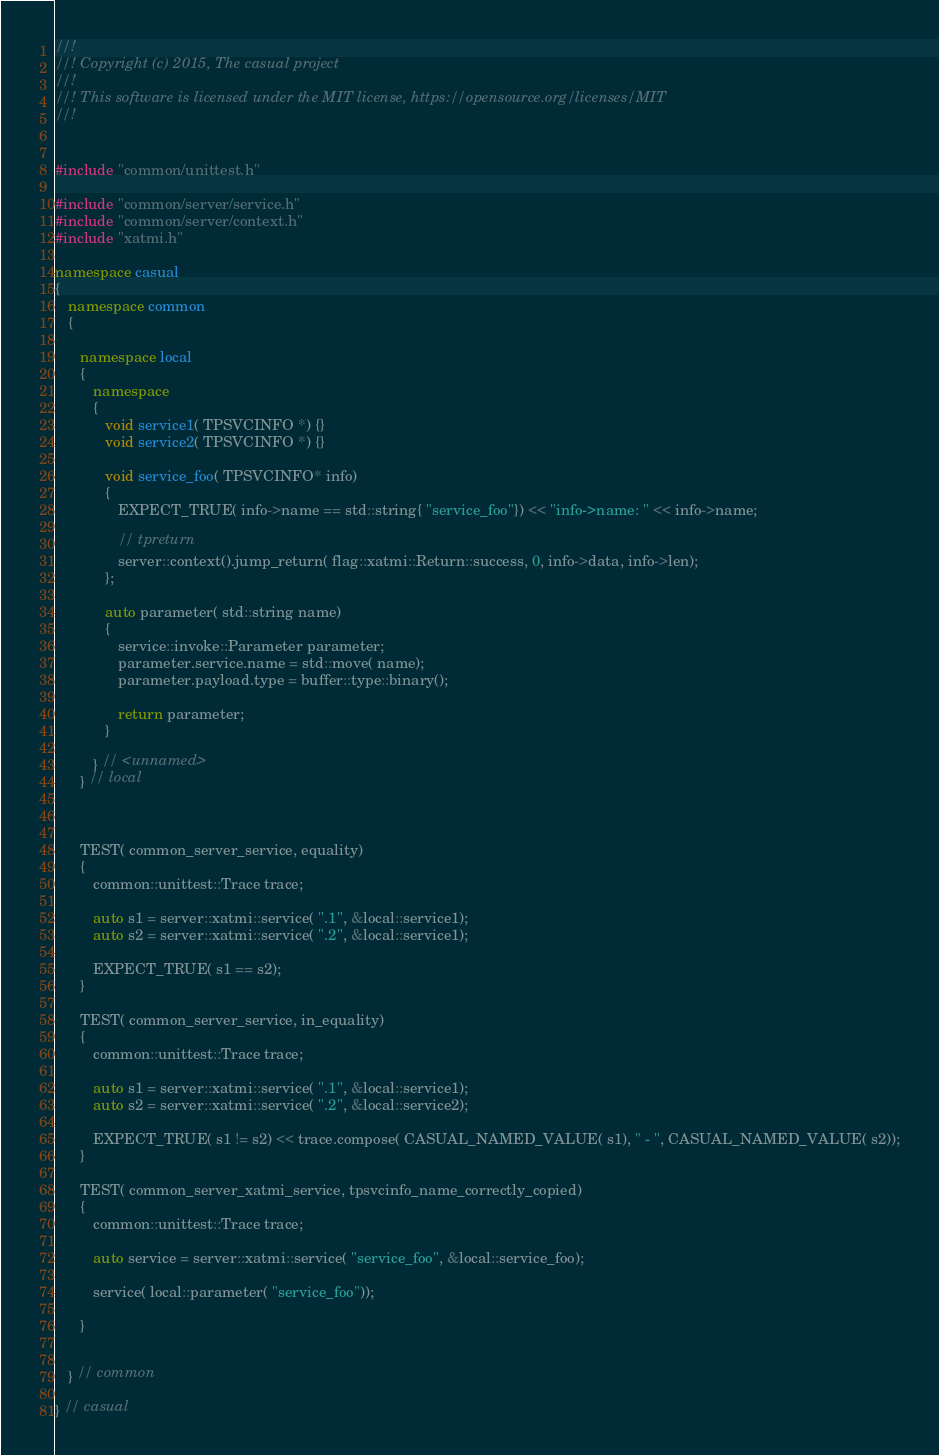Convert code to text. <code><loc_0><loc_0><loc_500><loc_500><_C++_>//! 
//! Copyright (c) 2015, The casual project
//!
//! This software is licensed under the MIT license, https://opensource.org/licenses/MIT
//!


#include "common/unittest.h"

#include "common/server/service.h"
#include "common/server/context.h"
#include "xatmi.h"

namespace casual
{
   namespace common
   {

      namespace local
      {
         namespace
         {
            void service1( TPSVCINFO *) {}
            void service2( TPSVCINFO *) {}

            void service_foo( TPSVCINFO* info) 
            {
               EXPECT_TRUE( info->name == std::string{ "service_foo"}) << "info->name: " << info->name;
               
               // tpreturn
               server::context().jump_return( flag::xatmi::Return::success, 0, info->data, info->len);
            };

            auto parameter( std::string name)
            {
               service::invoke::Parameter parameter;
               parameter.service.name = std::move( name);
               parameter.payload.type = buffer::type::binary();
               
               return parameter;
            }

         } // <unnamed>
      } // local



      TEST( common_server_service, equality)
      {
         common::unittest::Trace trace;

         auto s1 = server::xatmi::service( ".1", &local::service1);
         auto s2 = server::xatmi::service( ".2", &local::service1);

         EXPECT_TRUE( s1 == s2);
      }

      TEST( common_server_service, in_equality)
      {
         common::unittest::Trace trace;

         auto s1 = server::xatmi::service( ".1", &local::service1);
         auto s2 = server::xatmi::service( ".2", &local::service2);

         EXPECT_TRUE( s1 != s2) << trace.compose( CASUAL_NAMED_VALUE( s1), " - ", CASUAL_NAMED_VALUE( s2));
      }

      TEST( common_server_xatmi_service, tpsvcinfo_name_correctly_copied)
      {
         common::unittest::Trace trace;

         auto service = server::xatmi::service( "service_foo", &local::service_foo);

         service( local::parameter( "service_foo"));

      }


   } // common

} // casual
</code> 